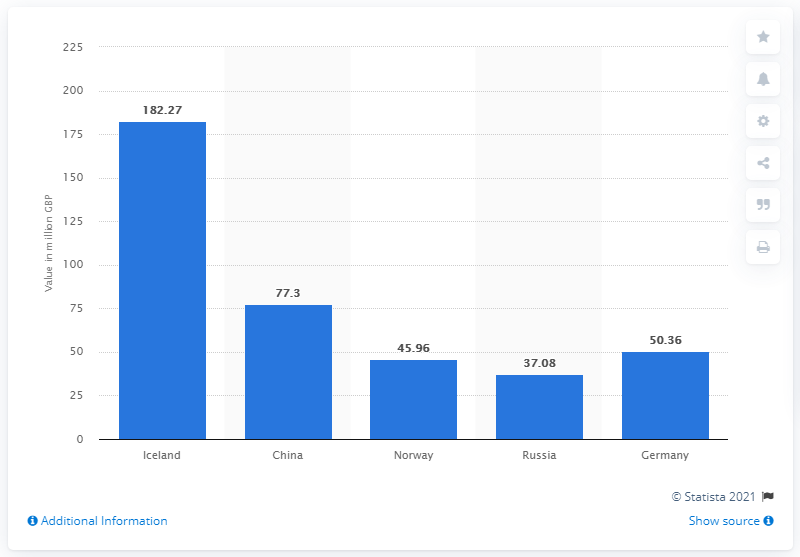List a handful of essential elements in this visual. In 2016, the UK imported 182.27 metric tons of cod from Iceland, worth a total of pounds. In 2016, cod was imported to the UK from Iceland. 